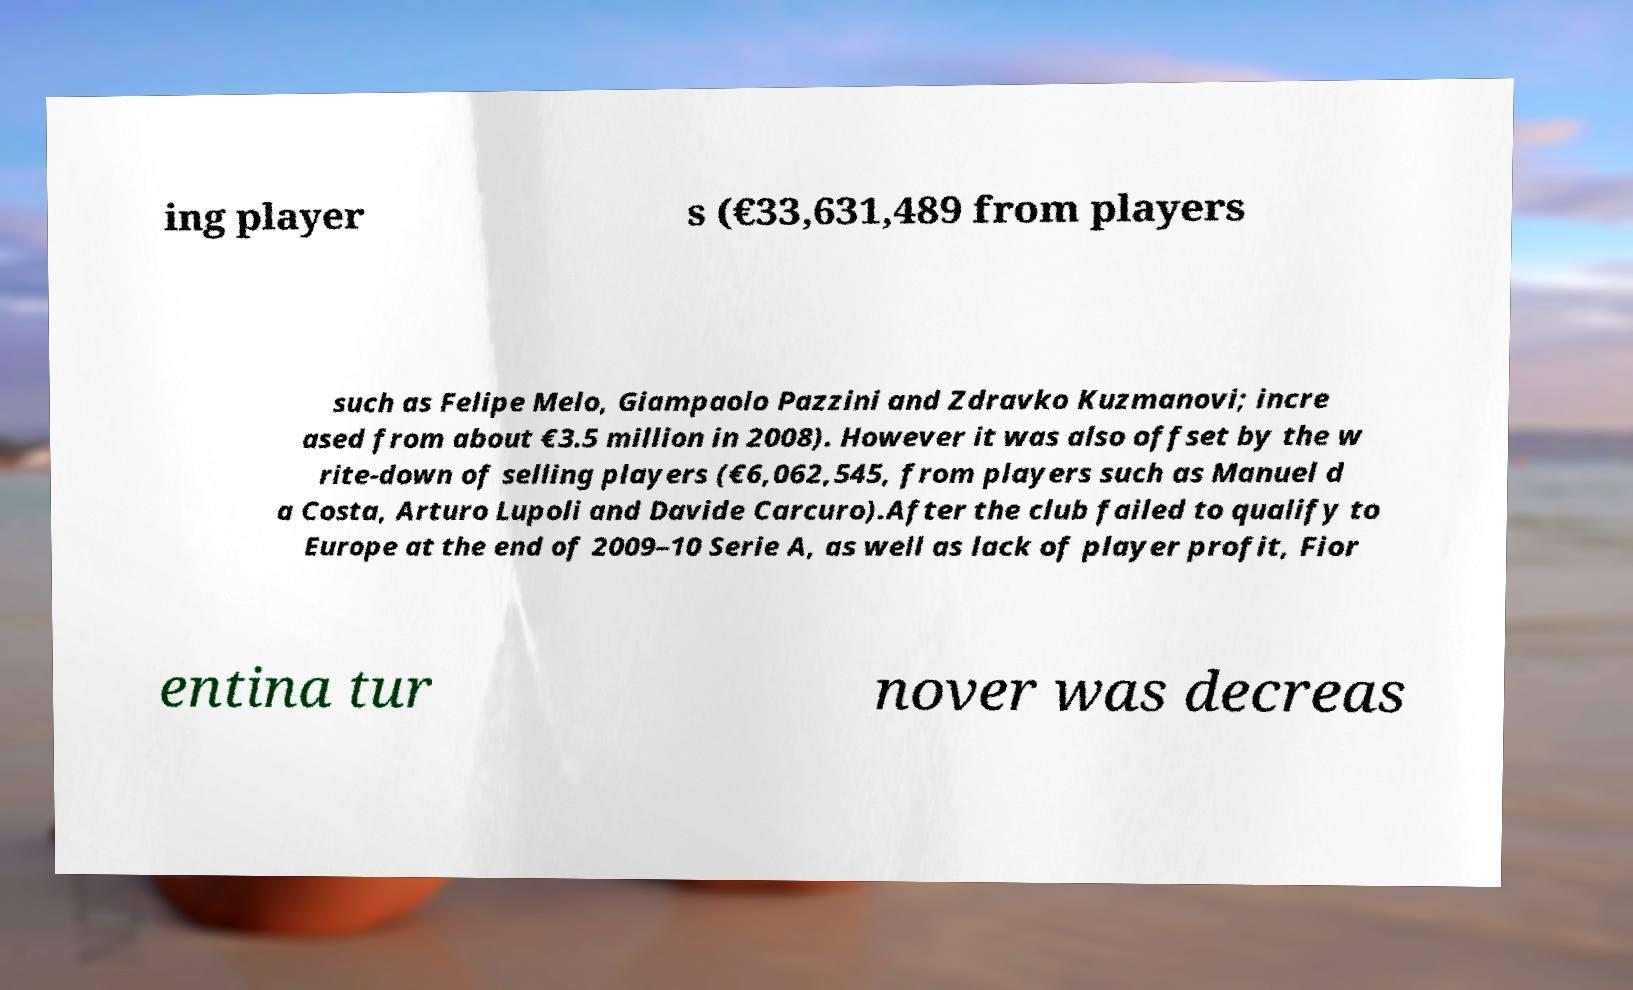Please read and relay the text visible in this image. What does it say? ing player s (€33,631,489 from players such as Felipe Melo, Giampaolo Pazzini and Zdravko Kuzmanovi; incre ased from about €3.5 million in 2008). However it was also offset by the w rite-down of selling players (€6,062,545, from players such as Manuel d a Costa, Arturo Lupoli and Davide Carcuro).After the club failed to qualify to Europe at the end of 2009–10 Serie A, as well as lack of player profit, Fior entina tur nover was decreas 